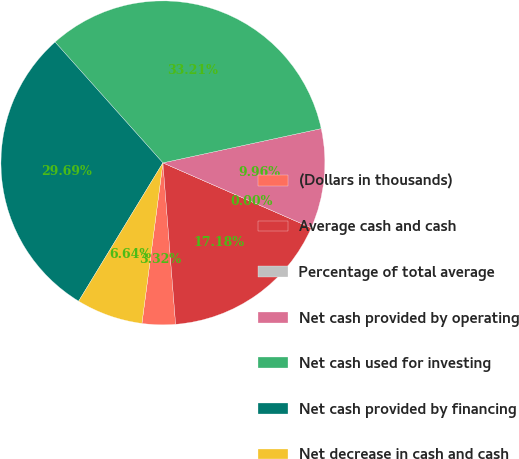Convert chart to OTSL. <chart><loc_0><loc_0><loc_500><loc_500><pie_chart><fcel>(Dollars in thousands)<fcel>Average cash and cash<fcel>Percentage of total average<fcel>Net cash provided by operating<fcel>Net cash used for investing<fcel>Net cash provided by financing<fcel>Net decrease in cash and cash<nl><fcel>3.32%<fcel>17.18%<fcel>0.0%<fcel>9.96%<fcel>33.21%<fcel>29.69%<fcel>6.64%<nl></chart> 